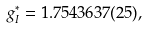<formula> <loc_0><loc_0><loc_500><loc_500>g ^ { * } _ { I } = 1 . 7 5 4 3 6 3 7 ( 2 5 ) ,</formula> 